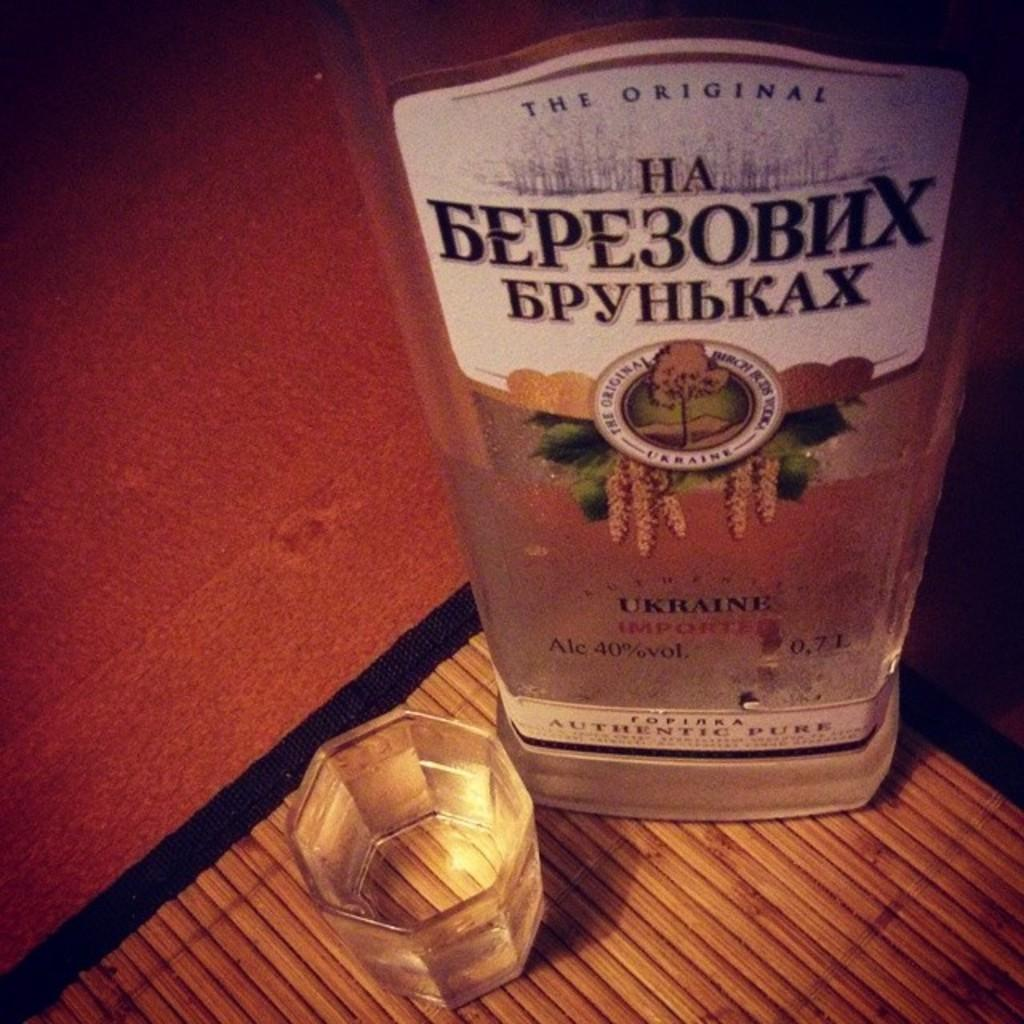What type of beverage container is in the image? There is a bottle of alcohol in the image. What is the glass object in the image used for? There is a tumbler in the image, which is typically used for drinking beverages. Where is the tumbler placed in the image? The tumbler is placed on a mat in the image. What type of appliance is visible in the image? There is no appliance present in the image. Can you describe the sink in the image? There is no sink present in the image. 